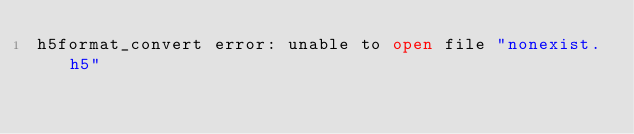<code> <loc_0><loc_0><loc_500><loc_500><_SQL_>h5format_convert error: unable to open file "nonexist.h5"
</code> 